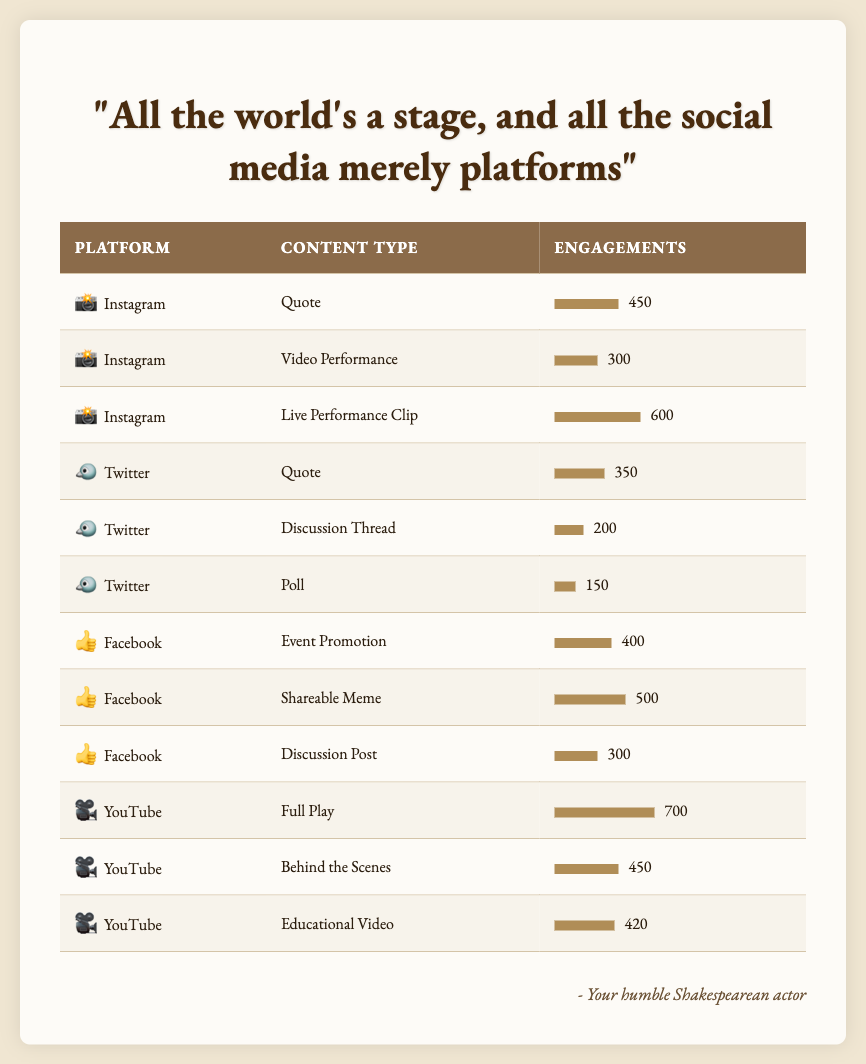What is the highest engagement level on Instagram? Looking at the Instagram section, the highest engagement is for the "Live Performance Clip," which has 600 engagements.
Answer: 600 What type of content on Twitter received the least engagements? For Twitter, the "Poll" has the least engagements with only 150.
Answer: 150 What is the total engagement for Facebook content? Adding the engagements: 400 (Event Promotion) + 500 (Shareable Meme) + 300 (Discussion Post) = 1200.
Answer: 1200 Is the engagement for "Behind the Scenes" content on YouTube greater than that for "Video Performance" on Instagram? "Behind the Scenes" has 450 engagements, while "Video Performance" on Instagram has 300 engagements, so yes, 450 is greater than 300.
Answer: Yes Which platform has the highest total engagements across all content types? Calculating total engagements: Instagram (450 + 300 + 600 = 1350), Twitter (350 + 200 + 150 = 700), Facebook (400 + 500 + 300 = 1200), YouTube (700 + 450 + 420 = 1570). YouTube has the highest with 1570 engagements.
Answer: YouTube 